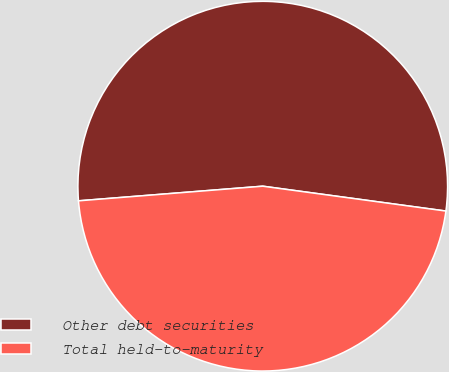Convert chart. <chart><loc_0><loc_0><loc_500><loc_500><pie_chart><fcel>Other debt securities<fcel>Total held-to-maturity<nl><fcel>53.41%<fcel>46.59%<nl></chart> 